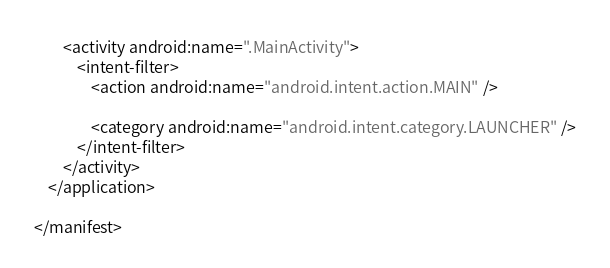<code> <loc_0><loc_0><loc_500><loc_500><_XML_>        <activity android:name=".MainActivity">
            <intent-filter>
                <action android:name="android.intent.action.MAIN" />

                <category android:name="android.intent.category.LAUNCHER" />
            </intent-filter>
        </activity>
    </application>

</manifest></code> 